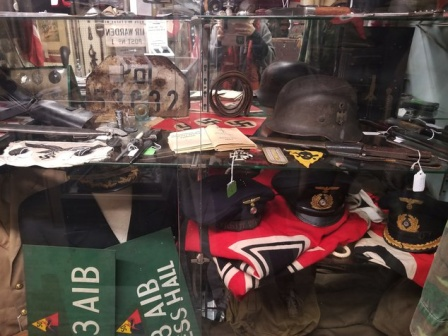Can you describe the types of uniforms visible in the display and their significance? The display features several types of uniforms, each steeped in historical significance. Prominently, there are peaked caps with distinct insignia, likely signifying ranks and affiliations within the military. These caps, worn by officers, symbolize command and the hierarchical structure pivotal during the war. The uniforms, composed of sturdy fabric to endure the harsh conditions of warfare, reflect the practicality and strategic design intended to provide both protection and mobility. The dark blue and black colors of some uniforms were typical of certain military branches, denoting unity and discipline. Each garment, with its unique insignia and detailing, represents the roles and responsibilities assigned to individuals, reflecting the diverse yet interconnected facets of the military machinery during World War II. What is the significance of the different badges and emblems on the uniforms? The badges and emblems adorning the uniforms are rich in symbolism and significance. Each badge often represents a specific battalion or division, showcasing the wearer's unit affiliation and fostering a sense of belonging and pride. Emblems may denote rank, displaying a soldier's position within the military hierarchy, from enlisted personnel to high-ranking officers. Some badges might signify special achievements or commendations, such as bravery in combat, exceptional service, or specialized skills. These symbols serve not only as identifiers but also as morale boosters, reminding soldiers of their accomplishments and their integral roles within the greater military framework. The meticulous design of each emblem is a testament to the honor and valor associated with military service. If the uniform could interact with us, what kind of message would it convey about its wearer? If the uniform could convey a message, it might share the journey of its wearer—beginning with the day it was first donned, filled with a mix of apprehension and resolve. The uniform would recount the long marches under the weight of sun and rain, the stains of mud and sweat marking arduous days. It would speak of the pride felt during parades and the solemnity during remembrance ceremonies. The uniform would bear witness to the camaraderie formed in the trenches, the unwavering spirit in the face of adversity, and the quiet moments of reflection under a starlit sky. It would tell stories of bravery, of battles fought and the silent mourning of lost friends. Ultimately, the uniform would embody the resilience, sacrifice, and unwavering dedication of its wearer, a silent testament to the trials endured and the legacies forged. Could these uniforms be part of a reenactment scenario? If so, describe it in detail. Indeed, these uniforms could play a pivotal role in a historical reenactment, bringing the past to life with vivid detail. Picture a reenactment set in a meticulously reconstructed World War II battlefield. The soldiers don authentic uniforms, complete with badges and emblems, stepping into roles that mirror the past with striking accuracy. The scene buzzes with anticipation as officers with peaked caps deliver rousing speeches, their voices carrying the weight of history. Soldiers in dark blue and black uniforms perform drills, their every move a rehearsal of precision and discipline. The sound of synchronized marching fills the air, resonating through the field as they mimic maneuvers learned through rigorous training. Trenches are occupied by soldiers, their uniforms blending into the muddy backdrop, as they engage in staged combat, rifles firing blank rounds to simulate the intensity of historical skirmishes. The reenactment is not just a visual spectacle but an immersive experience, where spectators are transported to another era, witnessing the trials and triumphs of those who once wore these uniforms in earnest. 